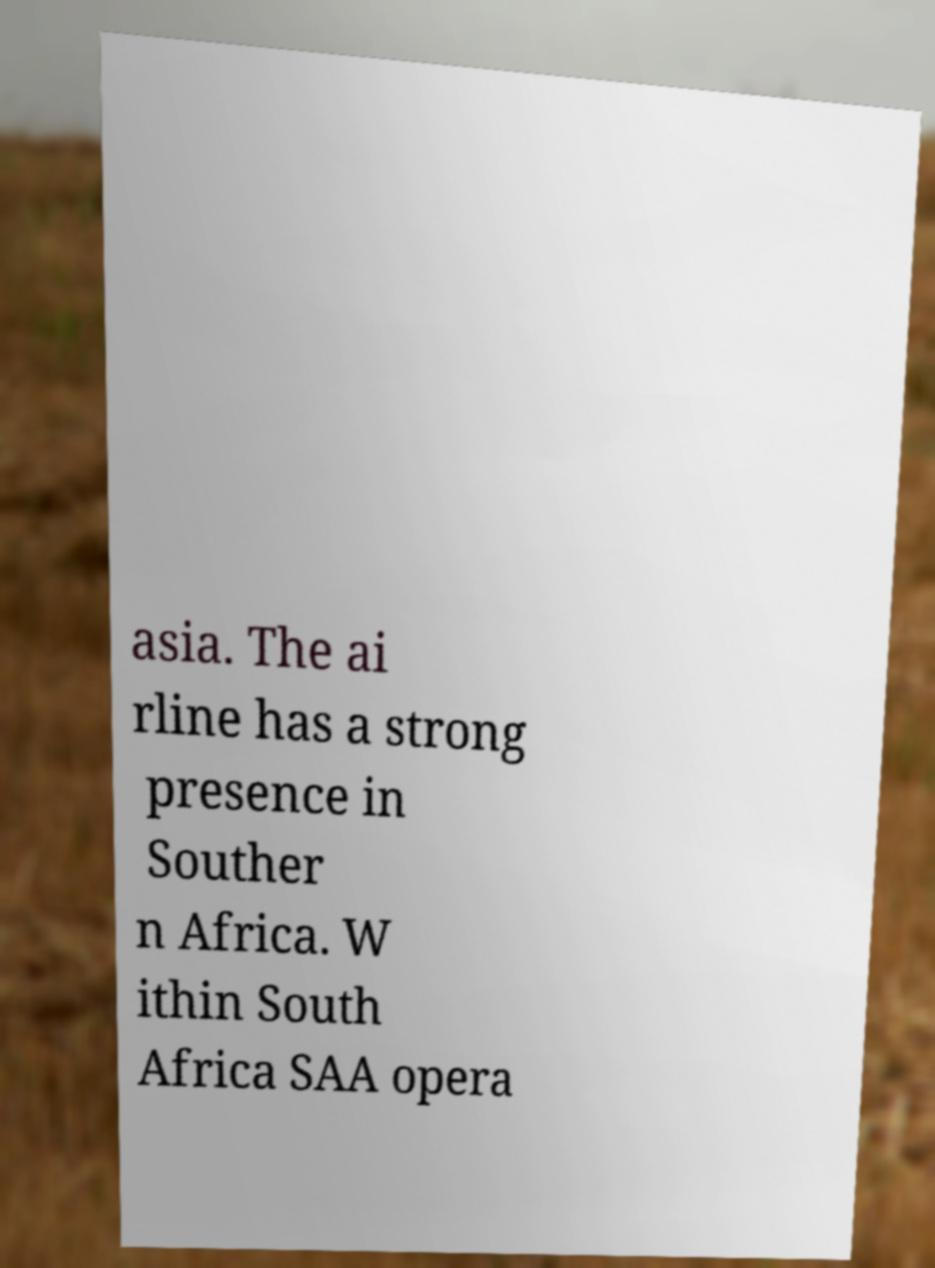Can you read and provide the text displayed in the image?This photo seems to have some interesting text. Can you extract and type it out for me? asia. The ai rline has a strong presence in Souther n Africa. W ithin South Africa SAA opera 